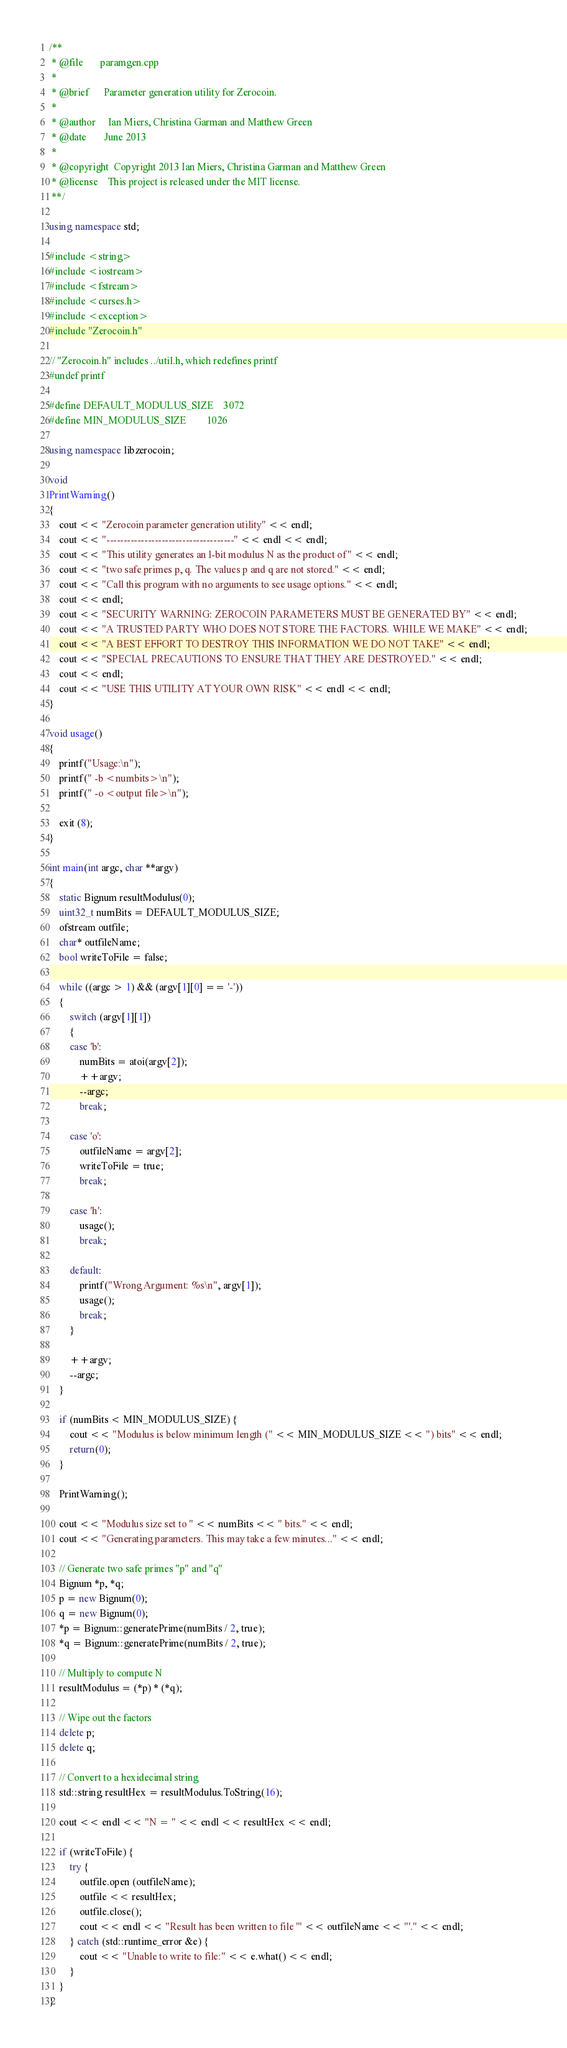<code> <loc_0><loc_0><loc_500><loc_500><_C++_>/**
 * @file       paramgen.cpp
 *
 * @brief      Parameter generation utility for Zerocoin.
 *
 * @author     Ian Miers, Christina Garman and Matthew Green
 * @date       June 2013
 *
 * @copyright  Copyright 2013 Ian Miers, Christina Garman and Matthew Green
 * @license    This project is released under the MIT license.
 **/

using namespace std;

#include <string>
#include <iostream>
#include <fstream>
#include <curses.h>
#include <exception>
#include "Zerocoin.h"

// "Zerocoin.h" includes ../util.h, which redefines printf
#undef printf

#define DEFAULT_MODULUS_SIZE    3072
#define MIN_MODULUS_SIZE        1026

using namespace libzerocoin;

void
PrintWarning()
{
	cout << "Zerocoin parameter generation utility" << endl;
	cout << "-------------------------------------" << endl << endl;
	cout << "This utility generates an l-bit modulus N as the product of" << endl;
	cout << "two safe primes p, q. The values p and q are not stored." << endl;
	cout << "Call this program with no arguments to see usage options." << endl;
	cout << endl;
	cout << "SECURITY WARNING: ZEROCOIN PARAMETERS MUST BE GENERATED BY" << endl;
	cout << "A TRUSTED PARTY WHO DOES NOT STORE THE FACTORS. WHILE WE MAKE" << endl;
	cout << "A BEST EFFORT TO DESTROY THIS INFORMATION WE DO NOT TAKE" << endl;
	cout << "SPECIAL PRECAUTIONS TO ENSURE THAT THEY ARE DESTROYED." << endl;
	cout << endl;
	cout << "USE THIS UTILITY AT YOUR OWN RISK" << endl << endl;
}

void usage()
{
	printf("Usage:\n");
	printf(" -b <numbits>\n");
	printf(" -o <output file>\n");

	exit (8);
}

int main(int argc, char **argv)
{
	static Bignum resultModulus(0);
	uint32_t numBits = DEFAULT_MODULUS_SIZE;
	ofstream outfile;
	char* outfileName;
	bool writeToFile = false;

	while ((argc > 1) && (argv[1][0] == '-'))
	{
		switch (argv[1][1])
		{
		case 'b':
			numBits = atoi(argv[2]);
			++argv;
			--argc;
			break;

		case 'o':
			outfileName = argv[2];
			writeToFile = true;
			break;

		case 'h':
			usage();
			break;

		default:
			printf("Wrong Argument: %s\n", argv[1]);
			usage();
			break;
		}

		++argv;
		--argc;
	}

	if (numBits < MIN_MODULUS_SIZE) {
		cout << "Modulus is below minimum length (" << MIN_MODULUS_SIZE << ") bits" << endl;
		return(0);
	}

	PrintWarning();

	cout << "Modulus size set to " << numBits << " bits." << endl;
	cout << "Generating parameters. This may take a few minutes..." << endl;

	// Generate two safe primes "p" and "q"
	Bignum *p, *q;
	p = new Bignum(0);
	q = new Bignum(0);
	*p = Bignum::generatePrime(numBits / 2, true);
	*q = Bignum::generatePrime(numBits / 2, true);

	// Multiply to compute N
	resultModulus = (*p) * (*q);

	// Wipe out the factors
	delete p;
	delete q;

	// Convert to a hexidecimal string
	std::string resultHex = resultModulus.ToString(16);

	cout << endl << "N = " << endl << resultHex << endl;

	if (writeToFile) {
		try {
			outfile.open (outfileName);
			outfile << resultHex;
			outfile.close();
			cout << endl << "Result has been written to file '" << outfileName << "'." << endl;
		} catch (std::runtime_error &e) {
			cout << "Unable to write to file:" << e.what() << endl;
		}
	}
}
</code> 